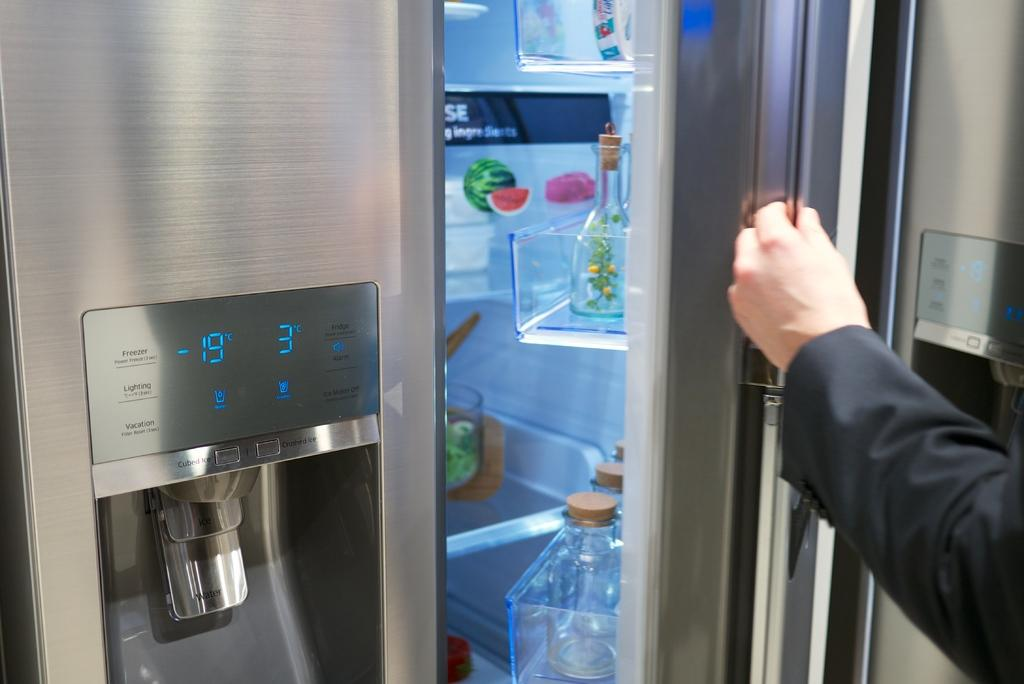<image>
Provide a brief description of the given image. A fridge's display says the refrigerator is -19 degrees Celsius. 